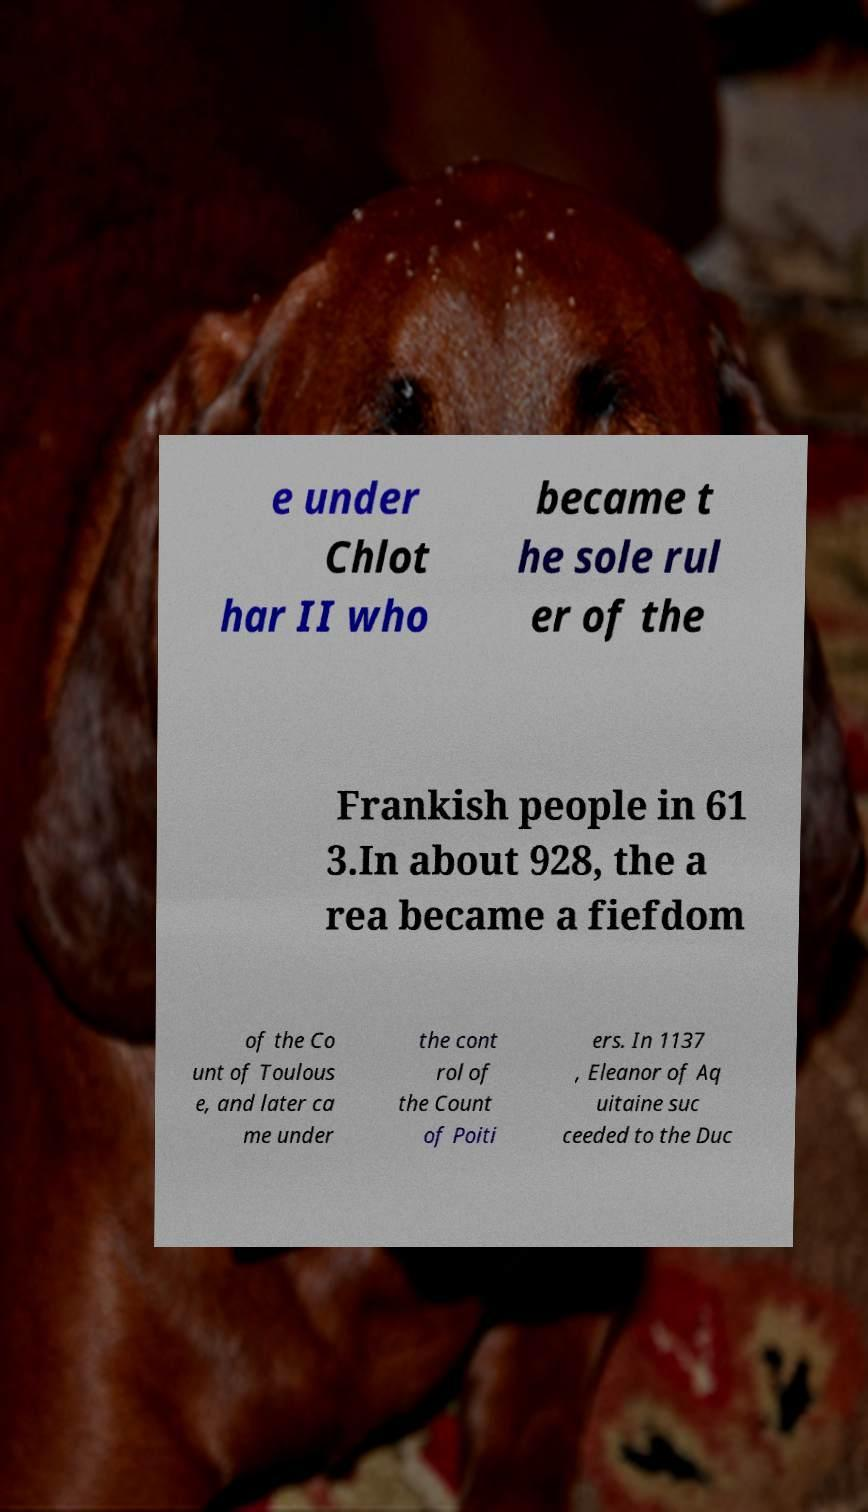Can you accurately transcribe the text from the provided image for me? e under Chlot har II who became t he sole rul er of the Frankish people in 61 3.In about 928, the a rea became a fiefdom of the Co unt of Toulous e, and later ca me under the cont rol of the Count of Poiti ers. In 1137 , Eleanor of Aq uitaine suc ceeded to the Duc 